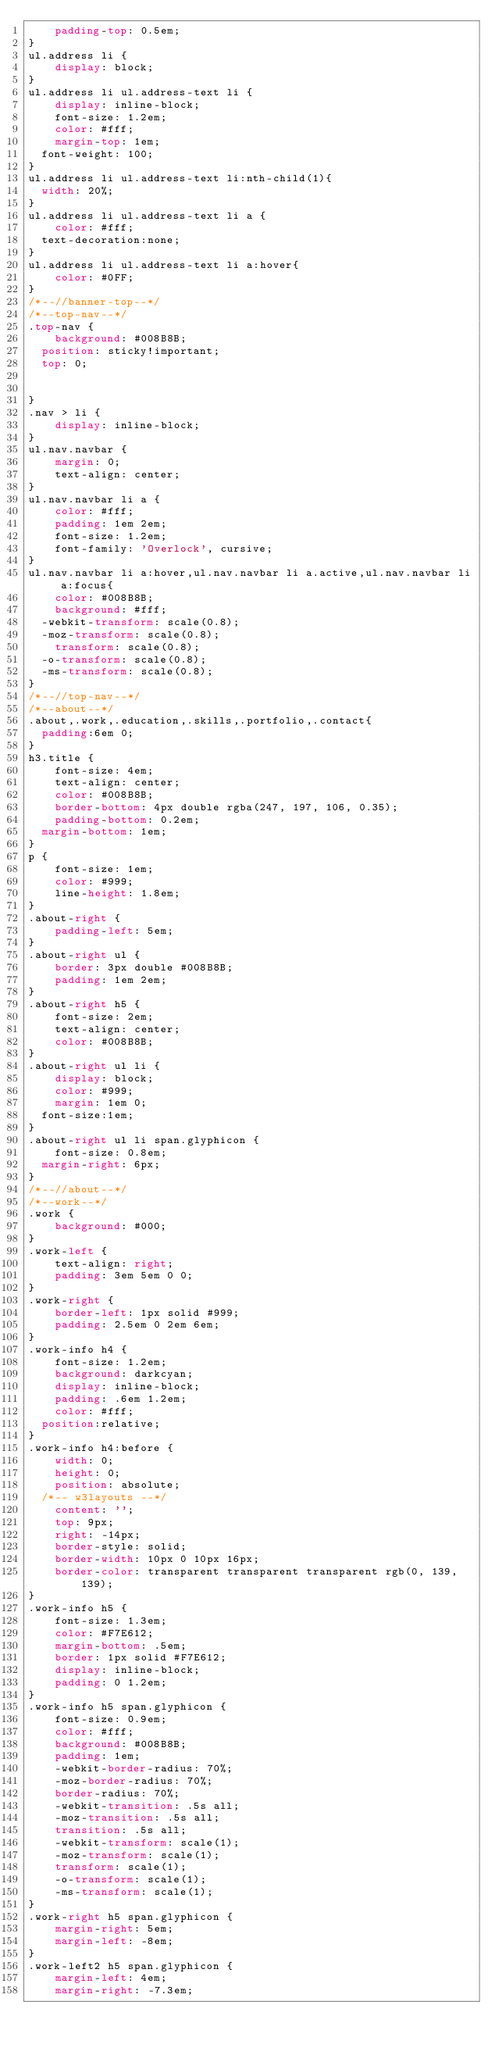<code> <loc_0><loc_0><loc_500><loc_500><_CSS_>    padding-top: 0.5em;
}
ul.address li {
    display: block;
}
ul.address li ul.address-text li {
    display: inline-block;
    font-size: 1.2em;
    color: #fff;
    margin-top: 1em;
	font-weight: 100;
}
ul.address li ul.address-text li:nth-child(1){
	width: 20%;
}
ul.address li ul.address-text li a {
    color: #fff;
	text-decoration:none;
}
ul.address li ul.address-text li a:hover{
    color: #0FF;
}
/*--//banner-top--*/
/*--top-nav--*/
.top-nav {
    background: #008B8B;
	position: sticky!important;
	top: 0;
	

}
.nav > li {
    display: inline-block;
}
ul.nav.navbar {
    margin: 0;
    text-align: center;
}
ul.nav.navbar li a {
    color: #fff;
    padding: 1em 2em;
    font-size: 1.2em;
    font-family: 'Overlock', cursive;
}
ul.nav.navbar li a:hover,ul.nav.navbar li a.active,ul.nav.navbar li a:focus{
    color: #008B8B;
    background: #fff;
	-webkit-transform: scale(0.8);
	-moz-transform: scale(0.8);
    transform: scale(0.8);
	-o-transform: scale(0.8);
	-ms-transform: scale(0.8);
}
/*--//top-nav--*/
/*--about--*/
.about,.work,.education,.skills,.portfolio,.contact{
	padding:6em 0;
}
h3.title {
    font-size: 4em;
    text-align: center;
    color: #008B8B;
    border-bottom: 4px double rgba(247, 197, 106, 0.35);
    padding-bottom: 0.2em;
	margin-bottom: 1em;
}
p {
    font-size: 1em;
    color: #999;
    line-height: 1.8em;
}
.about-right {
    padding-left: 5em;
}
.about-right ul {
    border: 3px double #008B8B;
    padding: 1em 2em;
}
.about-right h5 {
    font-size: 2em;
    text-align: center;
    color: #008B8B;
}
.about-right ul li {
    display: block;
    color: #999;
    margin: 1em 0;
	font-size:1em;
}
.about-right ul li span.glyphicon {
    font-size: 0.8em;
	margin-right: 6px;
}
/*--//about--*/
/*--work--*/
.work {
    background: #000;
}
.work-left {
    text-align: right;
    padding: 3em 5em 0 0;
}
.work-right {
    border-left: 1px solid #999;
    padding: 2.5em 0 2em 6em;
}
.work-info h4 {
    font-size: 1.2em;
    background: darkcyan;
    display: inline-block;
    padding: .6em 1.2em;
    color: #fff;
	position:relative;
}
.work-info h4:before {
    width: 0;
    height: 0;
    position: absolute;
	/*-- w3layouts --*/
    content: '';
    top: 9px;
    right: -14px;
    border-style: solid;
    border-width: 10px 0 10px 16px;
    border-color: transparent transparent transparent rgb(0, 139, 139);
}
.work-info h5 {
    font-size: 1.3em;
    color: #F7E612;
    margin-bottom: .5em;
    border: 1px solid #F7E612;
    display: inline-block;
    padding: 0 1.2em;
}
.work-info h5 span.glyphicon {
    font-size: 0.9em;
    color: #fff;
    background: #008B8B;
    padding: 1em;
    -webkit-border-radius: 70%;
    -moz-border-radius: 70%;
    border-radius: 70%;
    -webkit-transition: .5s all;
    -moz-transition: .5s all;
    transition: .5s all;
    -webkit-transform: scale(1);
    -moz-transform: scale(1);
    transform: scale(1);
    -o-transform: scale(1);
    -ms-transform: scale(1);
}
.work-right h5 span.glyphicon {
    margin-right: 5em;
    margin-left: -8em;
}
.work-left2 h5 span.glyphicon {
    margin-left: 4em;
    margin-right: -7.3em;</code> 